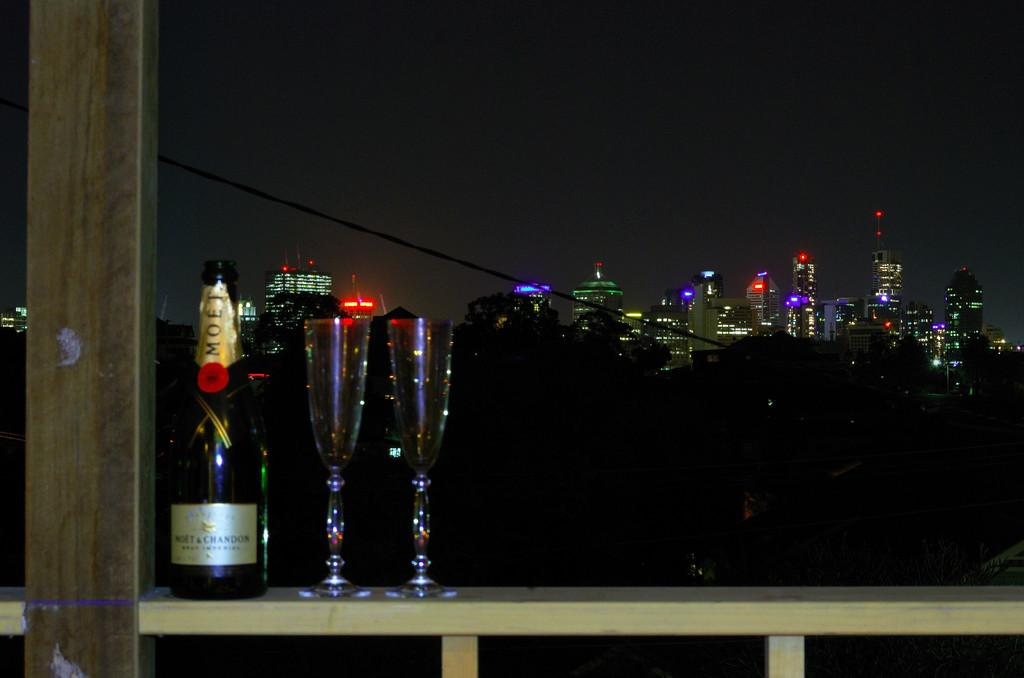Provide a one-sentence caption for the provided image. Two champagne flutes are ready for the Moet to be poured. 